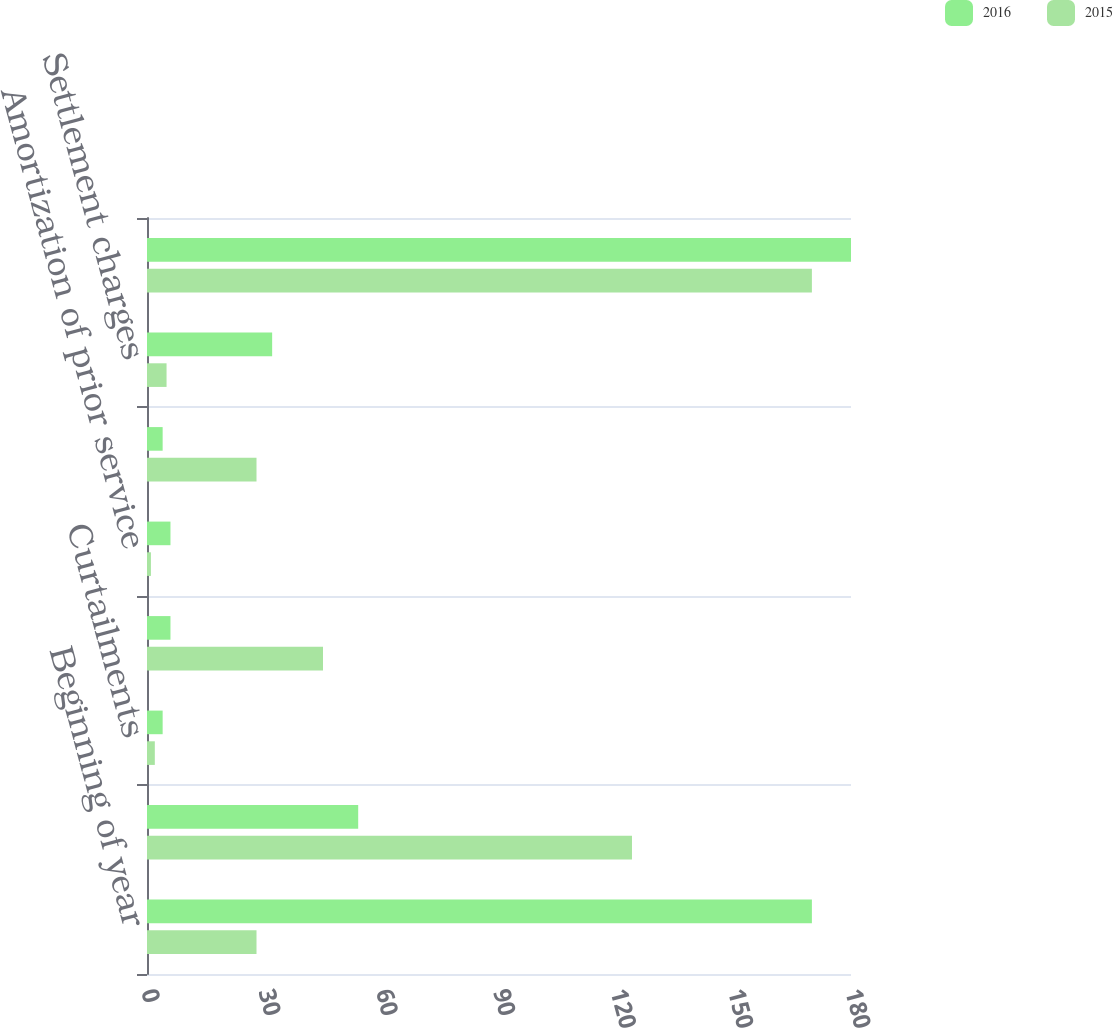<chart> <loc_0><loc_0><loc_500><loc_500><stacked_bar_chart><ecel><fcel>Beginning of year<fcel>Net actuarial gain (loss)<fcel>Curtailments<fcel>Amortization of net loss<fcel>Amortization of prior service<fcel>Prior service cost<fcel>Settlement charges<fcel>End of year<nl><fcel>2016<fcel>170<fcel>54<fcel>4<fcel>6<fcel>6<fcel>4<fcel>32<fcel>180<nl><fcel>2015<fcel>28<fcel>124<fcel>2<fcel>45<fcel>1<fcel>28<fcel>5<fcel>170<nl></chart> 